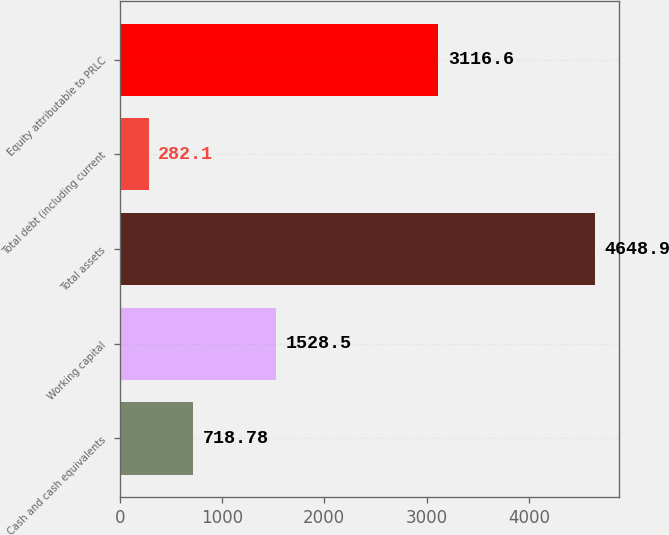Convert chart. <chart><loc_0><loc_0><loc_500><loc_500><bar_chart><fcel>Cash and cash equivalents<fcel>Working capital<fcel>Total assets<fcel>Total debt (including current<fcel>Equity attributable to PRLC<nl><fcel>718.78<fcel>1528.5<fcel>4648.9<fcel>282.1<fcel>3116.6<nl></chart> 